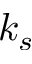Convert formula to latex. <formula><loc_0><loc_0><loc_500><loc_500>k _ { s }</formula> 